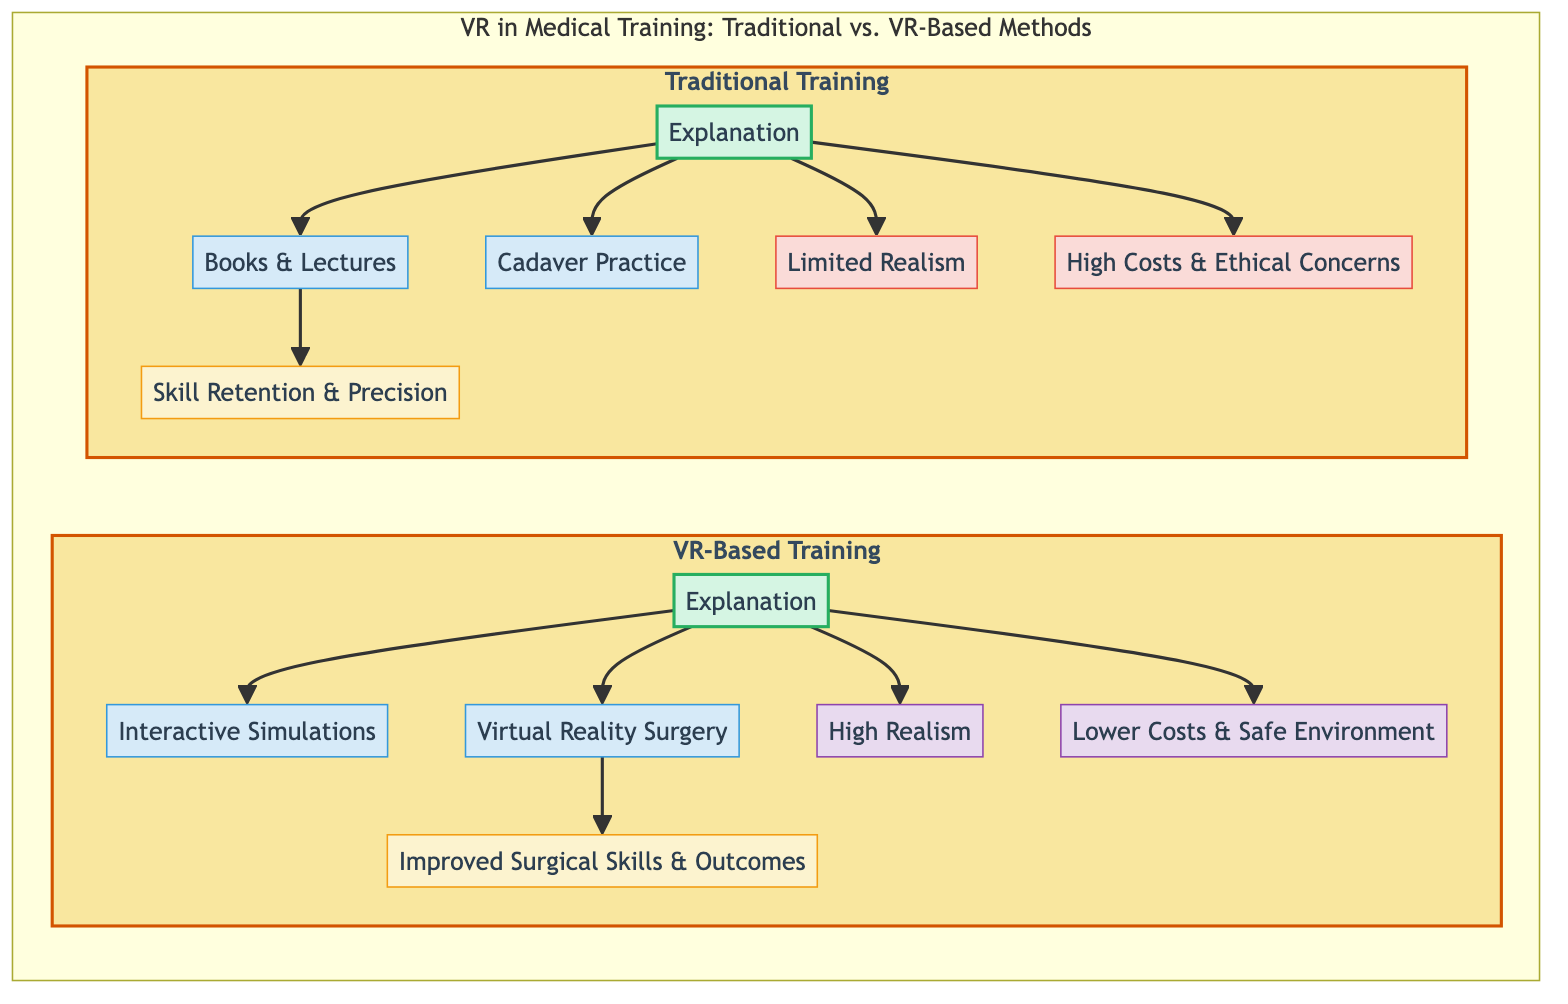What are the two main categories of training methods presented in the diagram? The diagram is organized into two main categories: Traditional Training and VR-Based Training. Each category encapsulates various components related to medical training methodologies.
Answer: Traditional Training and VR-Based Training What is one significant limitation of Traditional Training? The diagram lists Limited Realism and High Costs & Ethical Concerns as limitations of Traditional Training. Therefore, either of these could be a valid answer.
Answer: Limited Realism What type of method is Interactive Simulations categorized as? Interactive Simulations is classified under the method node in the VR-Based Training subsection of the diagram. This is indicated by its placement under the respective subgraph.
Answer: Method How does VR-Based Training improve outcomes compared to Traditional Training? According to the diagram, VR-Based Training leads to Improved Surgical Skills & Outcomes, which signifies a positive enhancement over Traditional Training.
Answer: Improved Surgical Skills & Outcomes Which training method has lower costs according to the diagram? The diagram clearly indicates that VR-Based Training has Lower Costs compared to Traditional Training, emphasizing a financial advantage inherent in the virtual training approach.
Answer: Lower Costs How many advantages of VR-Based Training are listed in the diagram? The diagram presents two advantages for VR-Based Training: High Realism and Lower Costs. By counting these nodes in the section dedicated to VR-Based Training, we confirm there are two advantages.
Answer: Two What is the relationship between Cadaver Practice and Skill Retention & Precision? In the traditional training section, Cadaver Practice (CP) points to Skill Retention & Precision (SR). This illustrates that one influences the other, emphasizing retains useful surgical skills.
Answer: Points to What does the section on VR-Based Training mainly focus on? The VR-Based Training section mainly focuses on methods like Interactive Simulations and Virtual Reality Surgery, along with their advantages and outcomes. This reflects a dedicated focus on exploring VR training outcomes.
Answer: Methods and Outcomes What advantage does High Realism offer to VR-Based Training? High Realism as an advantage suggests that VR-Based Training provides a more accurate and immersive training experience, which can enhance learning and skill acquisition. Essentially, it directly impacts the training quality.
Answer: A more accurate training experience How is the structure of the diagram organized? The structure of the diagram is organized as subgraphs for Traditional and VR-Based Training, with methodological categories, limitations, advantages, and outcomes clearly delineated. This organization allows for easy navigation through comparisons.
Answer: Subgraphs and categories 